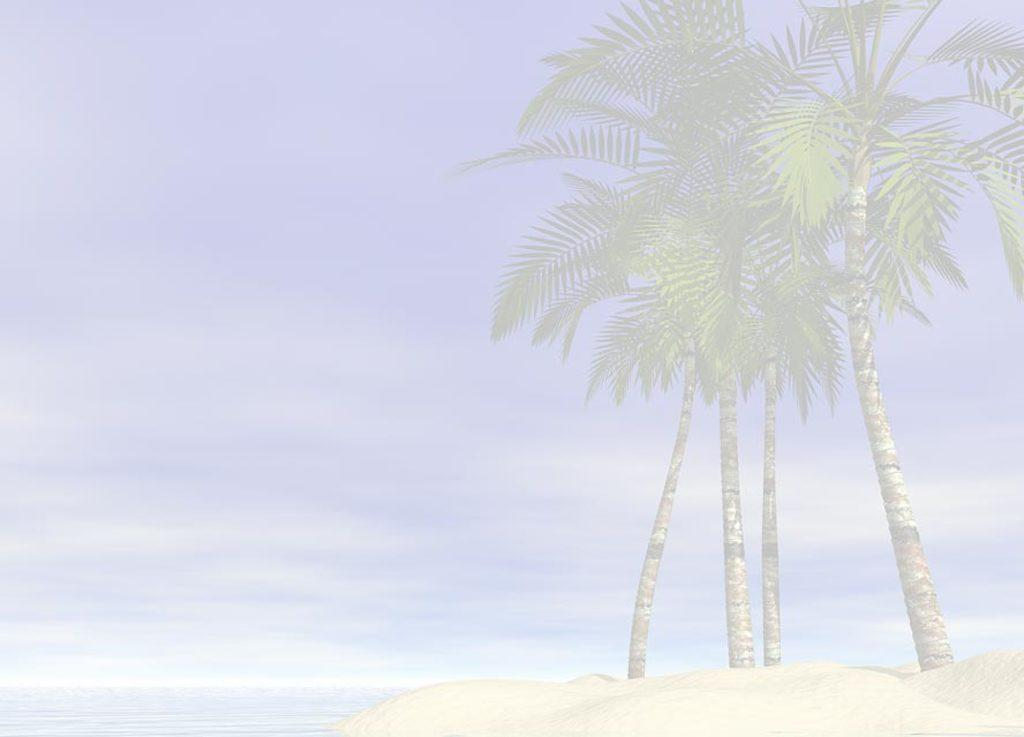What type of vegetation can be seen in the image? There are trees in the image. What color are the trees in the image? The trees are green in color. What is visible in the background of the image? The sky is visible in the background of the image. What colors can be seen in the sky in the image? The sky is blue and white in color. What type of shirt is the governor wearing in the image? There is no governor or shirt present in the image; it features trees and a blue and white sky. 